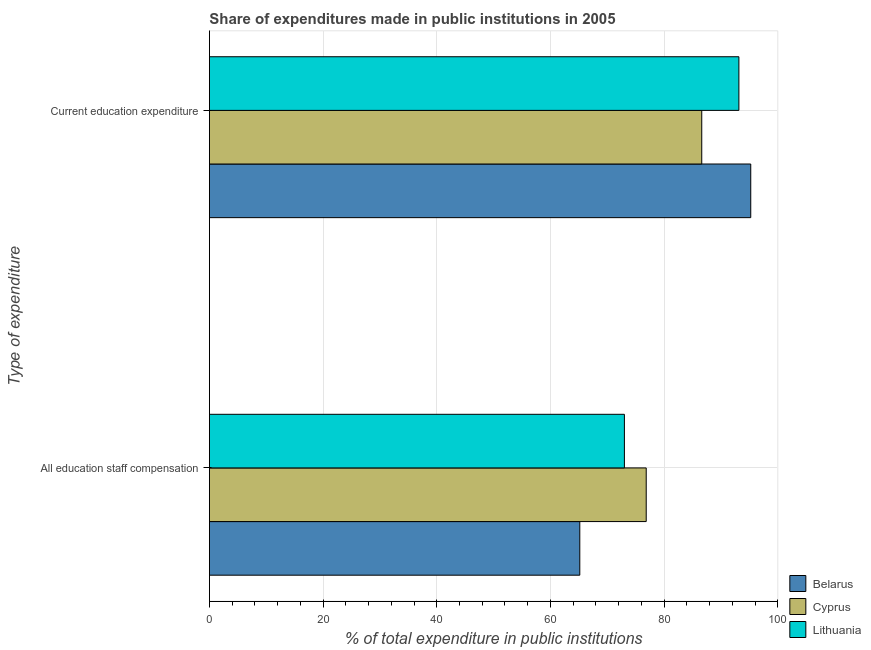How many different coloured bars are there?
Your answer should be compact. 3. Are the number of bars per tick equal to the number of legend labels?
Offer a terse response. Yes. How many bars are there on the 2nd tick from the top?
Your answer should be compact. 3. What is the label of the 2nd group of bars from the top?
Provide a short and direct response. All education staff compensation. What is the expenditure in education in Belarus?
Provide a succinct answer. 95.24. Across all countries, what is the maximum expenditure in education?
Give a very brief answer. 95.24. Across all countries, what is the minimum expenditure in staff compensation?
Keep it short and to the point. 65.17. In which country was the expenditure in staff compensation maximum?
Offer a very short reply. Cyprus. In which country was the expenditure in education minimum?
Your answer should be very brief. Cyprus. What is the total expenditure in education in the graph?
Your answer should be very brief. 275.02. What is the difference between the expenditure in education in Cyprus and that in Lithuania?
Provide a succinct answer. -6.53. What is the difference between the expenditure in education in Belarus and the expenditure in staff compensation in Cyprus?
Give a very brief answer. 18.39. What is the average expenditure in education per country?
Give a very brief answer. 91.67. What is the difference between the expenditure in staff compensation and expenditure in education in Lithuania?
Make the answer very short. -20.14. In how many countries, is the expenditure in staff compensation greater than 24 %?
Your answer should be very brief. 3. What is the ratio of the expenditure in education in Lithuania to that in Cyprus?
Offer a very short reply. 1.08. Is the expenditure in education in Belarus less than that in Lithuania?
Offer a very short reply. No. In how many countries, is the expenditure in staff compensation greater than the average expenditure in staff compensation taken over all countries?
Make the answer very short. 2. What does the 1st bar from the top in All education staff compensation represents?
Your answer should be compact. Lithuania. What does the 1st bar from the bottom in Current education expenditure represents?
Your response must be concise. Belarus. How many bars are there?
Provide a short and direct response. 6. How many countries are there in the graph?
Keep it short and to the point. 3. Does the graph contain grids?
Your answer should be compact. Yes. How many legend labels are there?
Your answer should be very brief. 3. What is the title of the graph?
Provide a short and direct response. Share of expenditures made in public institutions in 2005. What is the label or title of the X-axis?
Provide a succinct answer. % of total expenditure in public institutions. What is the label or title of the Y-axis?
Make the answer very short. Type of expenditure. What is the % of total expenditure in public institutions of Belarus in All education staff compensation?
Provide a succinct answer. 65.17. What is the % of total expenditure in public institutions of Cyprus in All education staff compensation?
Ensure brevity in your answer.  76.85. What is the % of total expenditure in public institutions in Lithuania in All education staff compensation?
Give a very brief answer. 73.01. What is the % of total expenditure in public institutions of Belarus in Current education expenditure?
Provide a short and direct response. 95.24. What is the % of total expenditure in public institutions in Cyprus in Current education expenditure?
Provide a succinct answer. 86.62. What is the % of total expenditure in public institutions in Lithuania in Current education expenditure?
Offer a terse response. 93.16. Across all Type of expenditure, what is the maximum % of total expenditure in public institutions of Belarus?
Your response must be concise. 95.24. Across all Type of expenditure, what is the maximum % of total expenditure in public institutions of Cyprus?
Your answer should be compact. 86.62. Across all Type of expenditure, what is the maximum % of total expenditure in public institutions of Lithuania?
Provide a short and direct response. 93.16. Across all Type of expenditure, what is the minimum % of total expenditure in public institutions of Belarus?
Your answer should be very brief. 65.17. Across all Type of expenditure, what is the minimum % of total expenditure in public institutions of Cyprus?
Give a very brief answer. 76.85. Across all Type of expenditure, what is the minimum % of total expenditure in public institutions of Lithuania?
Your answer should be compact. 73.01. What is the total % of total expenditure in public institutions of Belarus in the graph?
Give a very brief answer. 160.41. What is the total % of total expenditure in public institutions of Cyprus in the graph?
Your answer should be compact. 163.47. What is the total % of total expenditure in public institutions in Lithuania in the graph?
Your answer should be compact. 166.17. What is the difference between the % of total expenditure in public institutions of Belarus in All education staff compensation and that in Current education expenditure?
Your answer should be compact. -30.08. What is the difference between the % of total expenditure in public institutions in Cyprus in All education staff compensation and that in Current education expenditure?
Offer a terse response. -9.77. What is the difference between the % of total expenditure in public institutions in Lithuania in All education staff compensation and that in Current education expenditure?
Give a very brief answer. -20.14. What is the difference between the % of total expenditure in public institutions of Belarus in All education staff compensation and the % of total expenditure in public institutions of Cyprus in Current education expenditure?
Ensure brevity in your answer.  -21.46. What is the difference between the % of total expenditure in public institutions in Belarus in All education staff compensation and the % of total expenditure in public institutions in Lithuania in Current education expenditure?
Make the answer very short. -27.99. What is the difference between the % of total expenditure in public institutions in Cyprus in All education staff compensation and the % of total expenditure in public institutions in Lithuania in Current education expenditure?
Keep it short and to the point. -16.31. What is the average % of total expenditure in public institutions of Belarus per Type of expenditure?
Your response must be concise. 80.21. What is the average % of total expenditure in public institutions in Cyprus per Type of expenditure?
Your answer should be very brief. 81.74. What is the average % of total expenditure in public institutions of Lithuania per Type of expenditure?
Your response must be concise. 83.09. What is the difference between the % of total expenditure in public institutions of Belarus and % of total expenditure in public institutions of Cyprus in All education staff compensation?
Offer a terse response. -11.69. What is the difference between the % of total expenditure in public institutions of Belarus and % of total expenditure in public institutions of Lithuania in All education staff compensation?
Provide a short and direct response. -7.85. What is the difference between the % of total expenditure in public institutions of Cyprus and % of total expenditure in public institutions of Lithuania in All education staff compensation?
Your answer should be very brief. 3.84. What is the difference between the % of total expenditure in public institutions in Belarus and % of total expenditure in public institutions in Cyprus in Current education expenditure?
Your response must be concise. 8.62. What is the difference between the % of total expenditure in public institutions in Belarus and % of total expenditure in public institutions in Lithuania in Current education expenditure?
Offer a very short reply. 2.09. What is the difference between the % of total expenditure in public institutions of Cyprus and % of total expenditure in public institutions of Lithuania in Current education expenditure?
Provide a short and direct response. -6.53. What is the ratio of the % of total expenditure in public institutions of Belarus in All education staff compensation to that in Current education expenditure?
Your answer should be compact. 0.68. What is the ratio of the % of total expenditure in public institutions of Cyprus in All education staff compensation to that in Current education expenditure?
Ensure brevity in your answer.  0.89. What is the ratio of the % of total expenditure in public institutions of Lithuania in All education staff compensation to that in Current education expenditure?
Keep it short and to the point. 0.78. What is the difference between the highest and the second highest % of total expenditure in public institutions of Belarus?
Provide a short and direct response. 30.08. What is the difference between the highest and the second highest % of total expenditure in public institutions in Cyprus?
Offer a terse response. 9.77. What is the difference between the highest and the second highest % of total expenditure in public institutions in Lithuania?
Offer a terse response. 20.14. What is the difference between the highest and the lowest % of total expenditure in public institutions in Belarus?
Your answer should be compact. 30.08. What is the difference between the highest and the lowest % of total expenditure in public institutions of Cyprus?
Ensure brevity in your answer.  9.77. What is the difference between the highest and the lowest % of total expenditure in public institutions of Lithuania?
Offer a terse response. 20.14. 